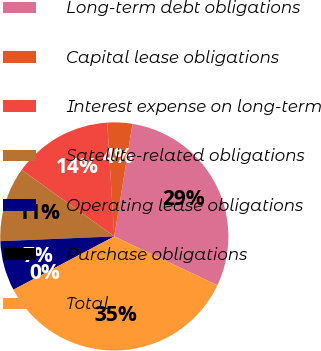Convert chart to OTSL. <chart><loc_0><loc_0><loc_500><loc_500><pie_chart><fcel>Long-term debt obligations<fcel>Capital lease obligations<fcel>Interest expense on long-term<fcel>Satellite-related obligations<fcel>Operating lease obligations<fcel>Purchase obligations<fcel>Total<nl><fcel>29.48%<fcel>3.54%<fcel>14.1%<fcel>10.58%<fcel>7.06%<fcel>0.02%<fcel>35.23%<nl></chart> 